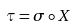<formula> <loc_0><loc_0><loc_500><loc_500>\tau = \sigma \circ X</formula> 